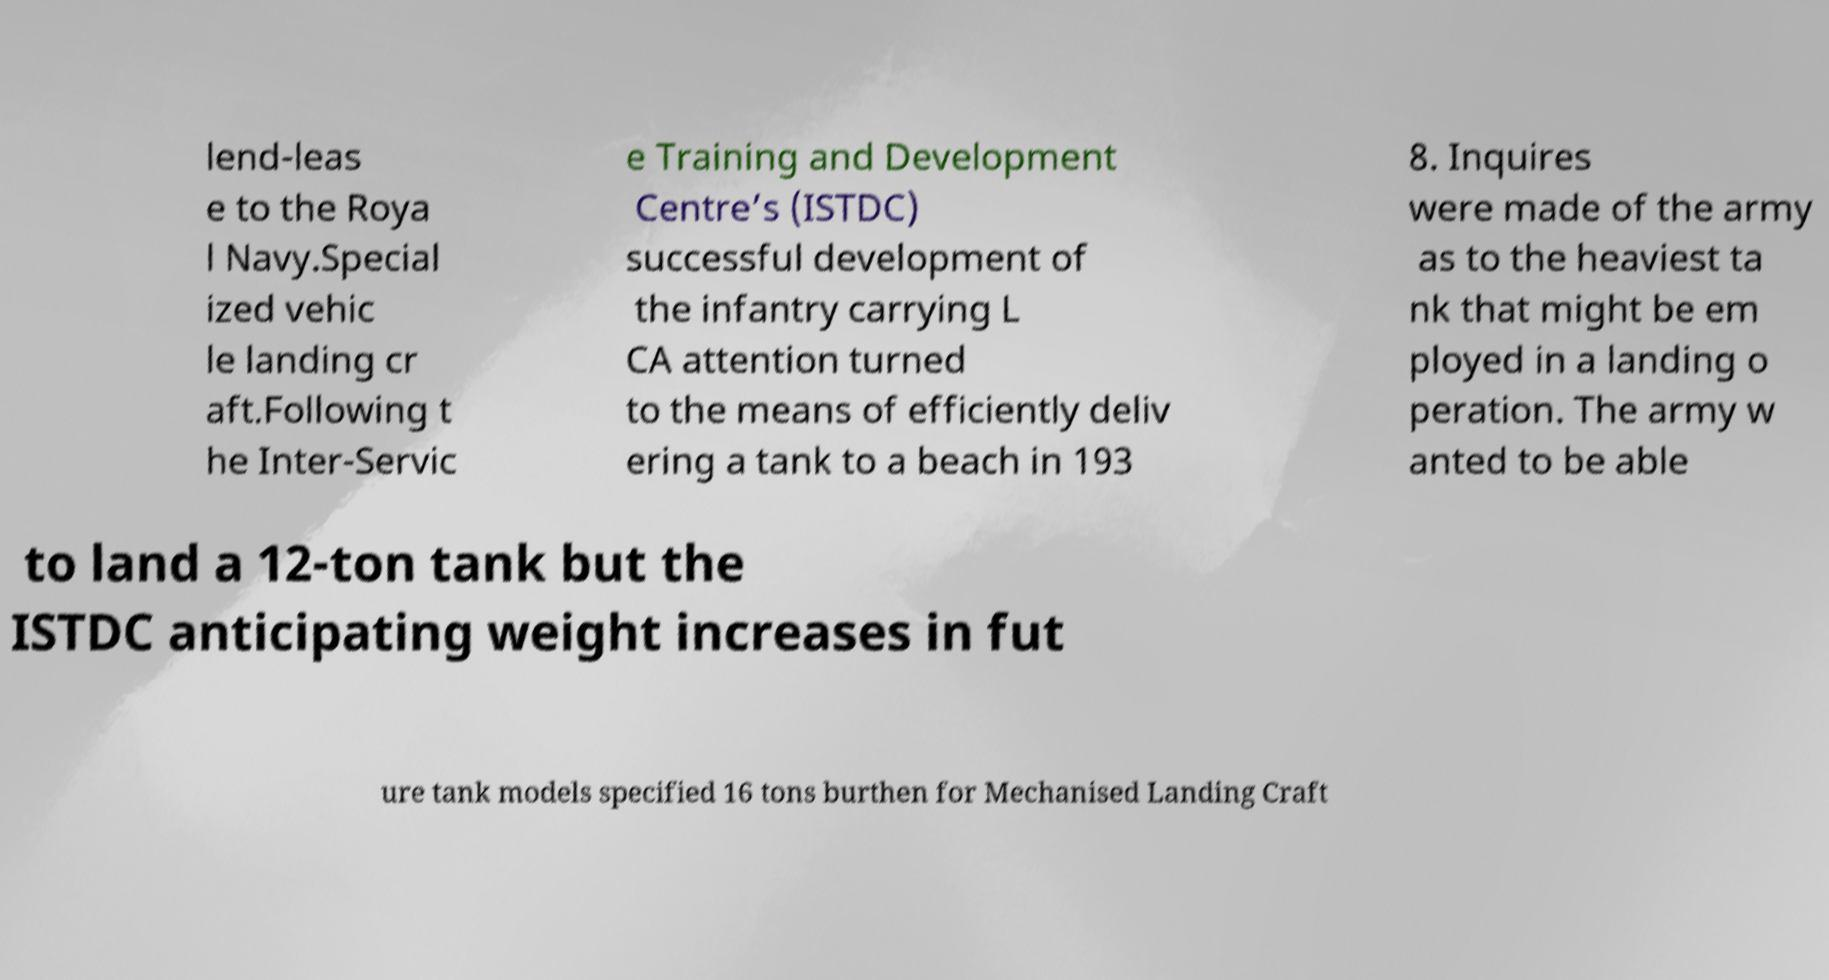What messages or text are displayed in this image? I need them in a readable, typed format. lend-leas e to the Roya l Navy.Special ized vehic le landing cr aft.Following t he Inter-Servic e Training and Development Centre’s (ISTDC) successful development of the infantry carrying L CA attention turned to the means of efficiently deliv ering a tank to a beach in 193 8. Inquires were made of the army as to the heaviest ta nk that might be em ployed in a landing o peration. The army w anted to be able to land a 12-ton tank but the ISTDC anticipating weight increases in fut ure tank models specified 16 tons burthen for Mechanised Landing Craft 